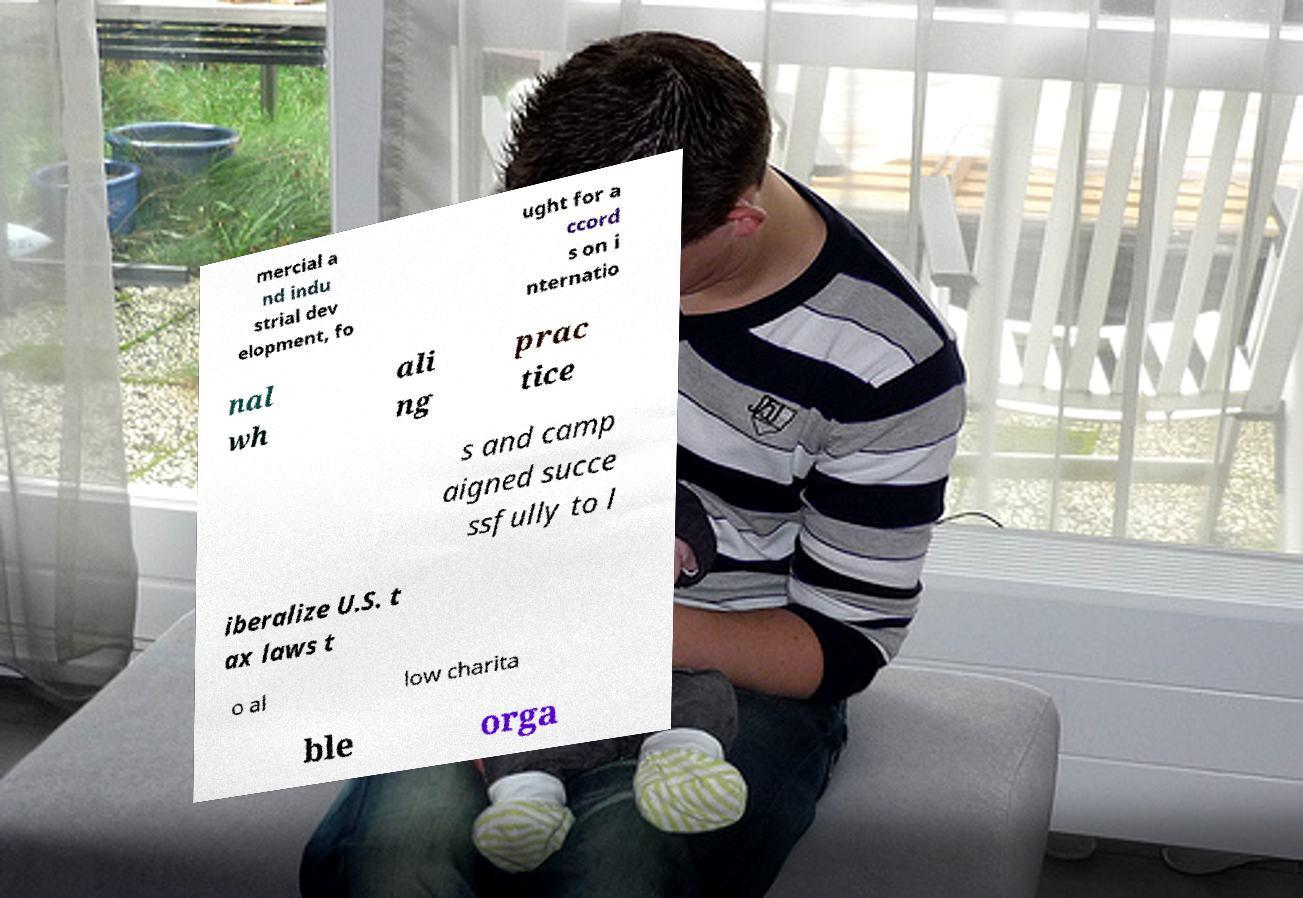Could you extract and type out the text from this image? mercial a nd indu strial dev elopment, fo ught for a ccord s on i nternatio nal wh ali ng prac tice s and camp aigned succe ssfully to l iberalize U.S. t ax laws t o al low charita ble orga 